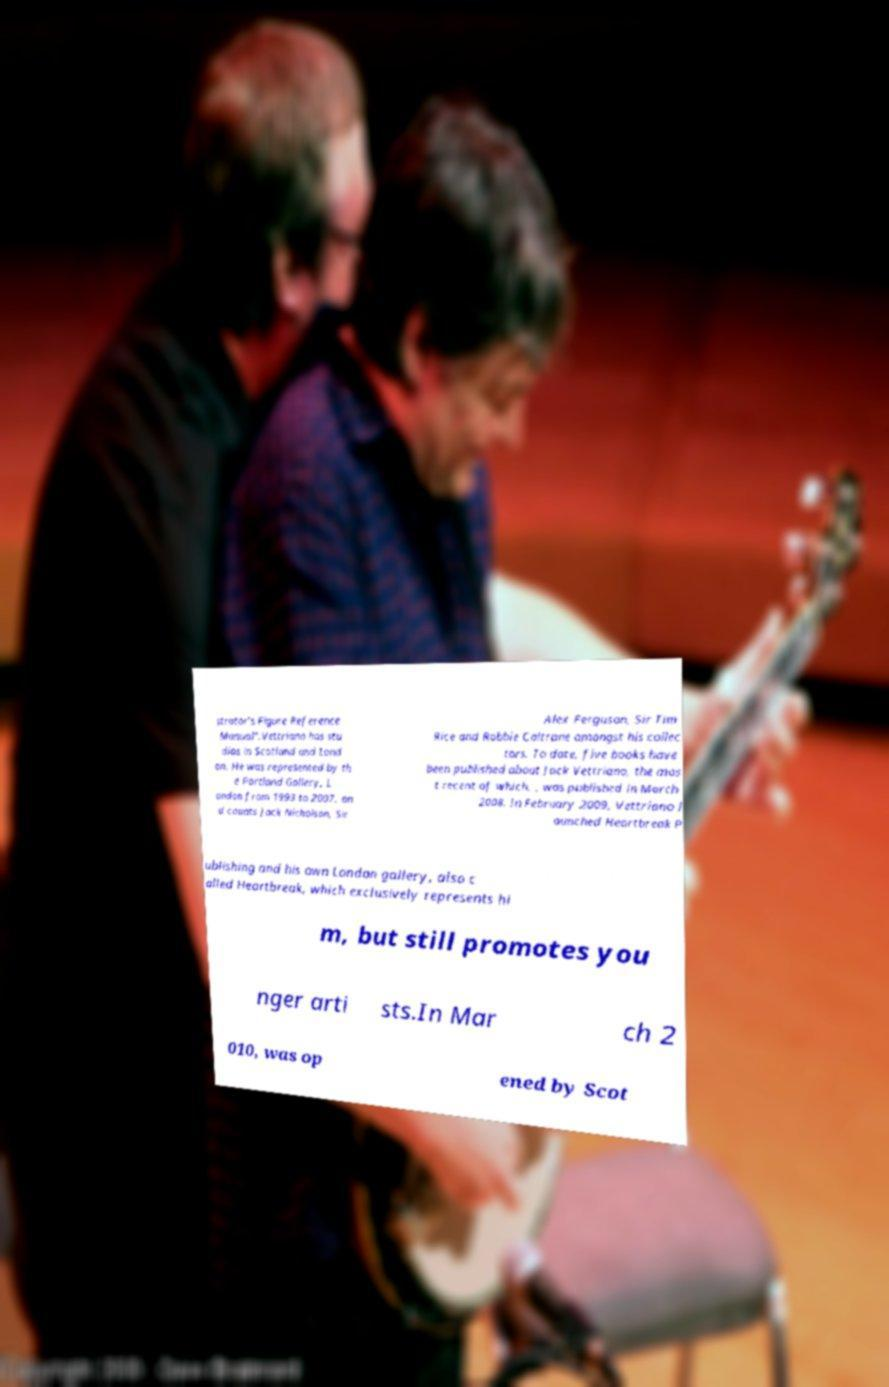Could you extract and type out the text from this image? strator’s Figure Reference Manual".Vettriano has stu dios in Scotland and Lond on. He was represented by th e Portland Gallery, L ondon from 1993 to 2007, an d counts Jack Nicholson, Sir Alex Ferguson, Sir Tim Rice and Robbie Coltrane amongst his collec tors. To date, five books have been published about Jack Vettriano, the mos t recent of which, , was published in March 2008. In February 2009, Vettriano l aunched Heartbreak P ublishing and his own London gallery, also c alled Heartbreak, which exclusively represents hi m, but still promotes you nger arti sts.In Mar ch 2 010, was op ened by Scot 